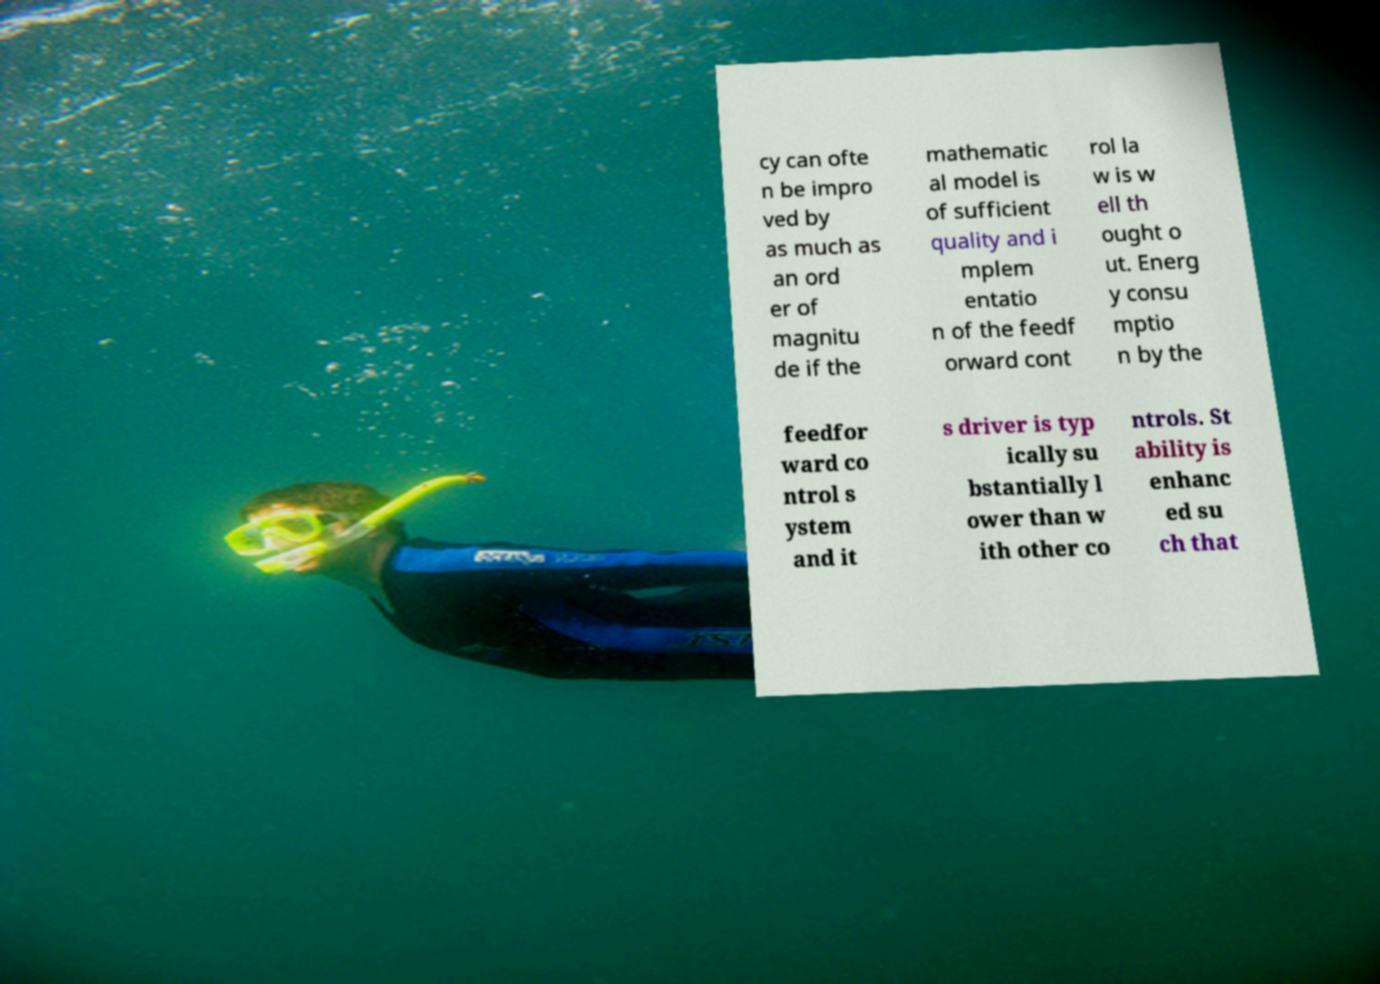Please identify and transcribe the text found in this image. cy can ofte n be impro ved by as much as an ord er of magnitu de if the mathematic al model is of sufficient quality and i mplem entatio n of the feedf orward cont rol la w is w ell th ought o ut. Energ y consu mptio n by the feedfor ward co ntrol s ystem and it s driver is typ ically su bstantially l ower than w ith other co ntrols. St ability is enhanc ed su ch that 